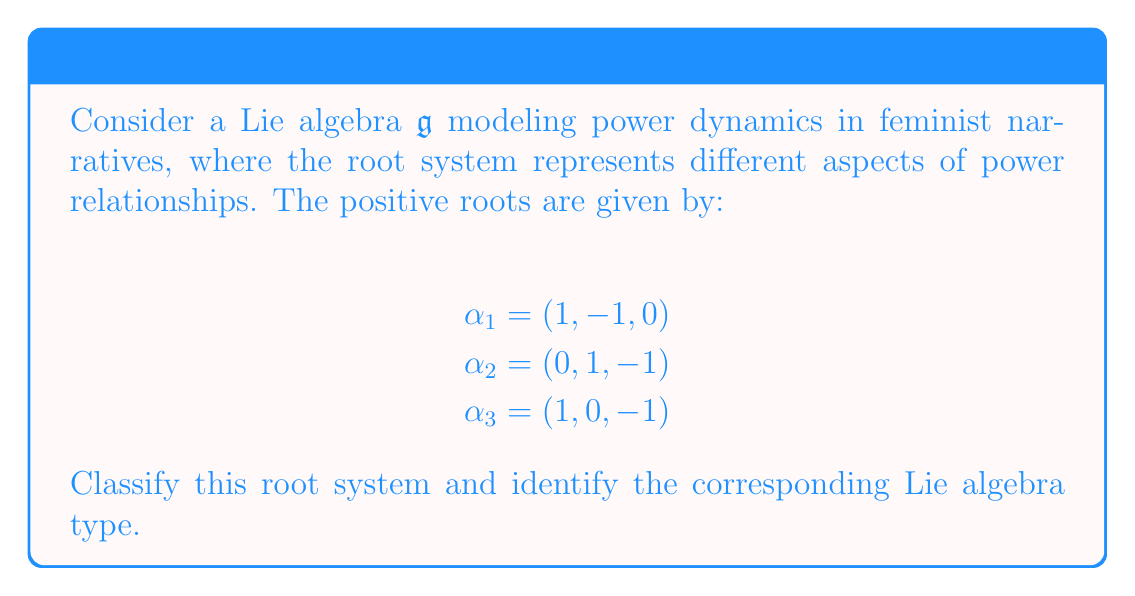Help me with this question. To classify the root system and identify the corresponding Lie algebra type, we'll follow these steps:

1) First, we need to determine the rank of the root system, which is the dimension of the space spanned by the roots. In this case, the roots are 3-dimensional vectors, so the rank is 3.

2) Next, we'll identify the simple roots. The given roots $\alpha_1$, $\alpha_2$, and $\alpha_3$ are already simple roots because none of them can be written as a positive linear combination of the others.

3) We can construct the Cartan matrix using the simple roots. The entries of the Cartan matrix are given by:

   $$a_{ij} = \frac{2(\alpha_i, \alpha_j)}{(\alpha_j, \alpha_j)}$$

   where $(\cdot,\cdot)$ denotes the standard inner product.

4) Calculating the Cartan matrix:

   $$A = \begin{pmatrix}
   2 & -1 & -1 \\
   -1 & 2 & -1 \\
   -1 & -1 & 2
   \end{pmatrix}$$

5) This Cartan matrix corresponds to the Dynkin diagram:

   [asy]
   unitsize(1cm);
   dot((0,0)); dot((1,0)); dot((0.5,0.866));
   draw((0,0)--(1,0));
   draw((0,0)--(0.5,0.866));
   draw((1,0)--(0.5,0.866));
   [/asy]

6) This Dynkin diagram and Cartan matrix are characteristic of the $A_3$ root system, which corresponds to the Lie algebra $\mathfrak{sl}(4, \mathbb{C})$ or $\mathfrak{su}(4)$.

In the context of feminist narratives, this $A_3$ structure could represent a system where power dynamics are influenced by three interconnected factors, each represented by a simple root. The symmetry of the Dynkin diagram suggests that these factors have equal importance and mutually influence each other in the power structure.
Answer: The root system is classified as $A_3$, corresponding to the Lie algebra $\mathfrak{sl}(4, \mathbb{C})$ or $\mathfrak{su}(4)$. 